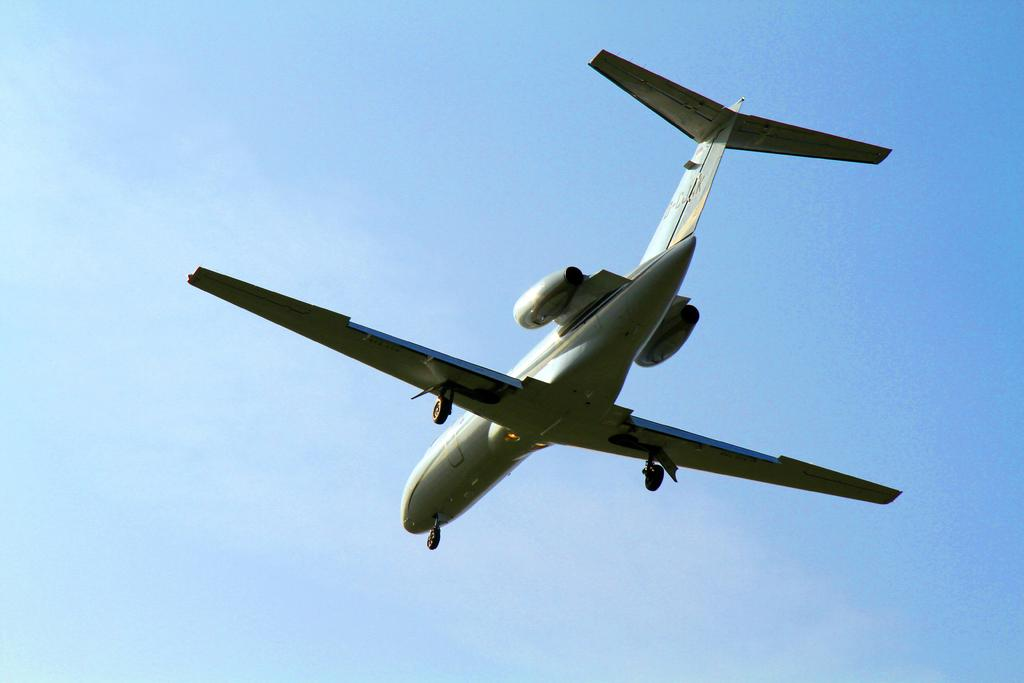What is the main subject of the image? The main subject of the image is an airplane. What can be seen in the background of the image? There is sky visible in the background of the image. Where is the yak located in the image? There is no yak present in the image. What type of brush can be seen in the image? There is no brush present in the image. 